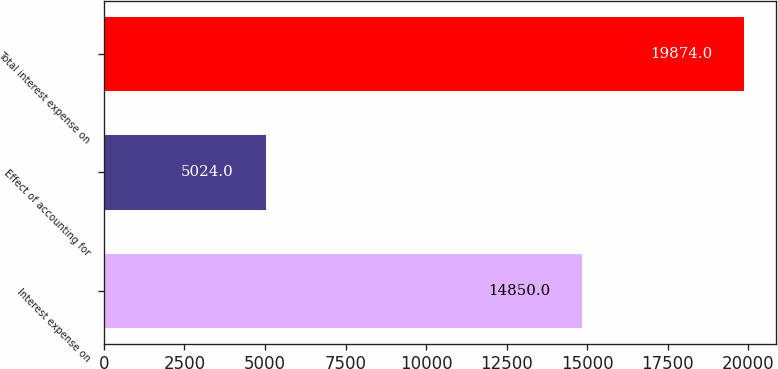Convert chart to OTSL. <chart><loc_0><loc_0><loc_500><loc_500><bar_chart><fcel>Interest expense on<fcel>Effect of accounting for<fcel>Total interest expense on<nl><fcel>14850<fcel>5024<fcel>19874<nl></chart> 